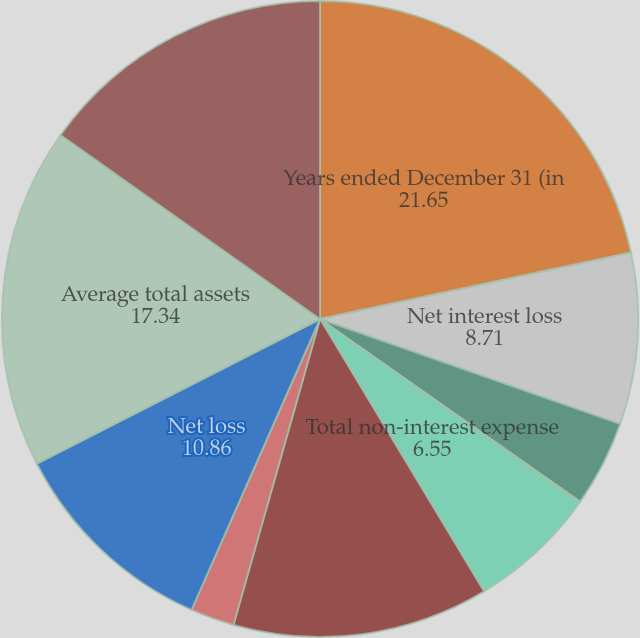<chart> <loc_0><loc_0><loc_500><loc_500><pie_chart><fcel>Years ended December 31 (in<fcel>Net interest loss<fcel>Provision for loan losses<fcel>Total non-interest income<fcel>Total non-interest expense<fcel>Loss before income tax benefit<fcel>Income tax benefit<fcel>Net loss<fcel>Average total assets<fcel>Average total liabilities<nl><fcel>21.65%<fcel>8.71%<fcel>4.39%<fcel>0.07%<fcel>6.55%<fcel>13.02%<fcel>2.23%<fcel>10.86%<fcel>17.34%<fcel>15.18%<nl></chart> 